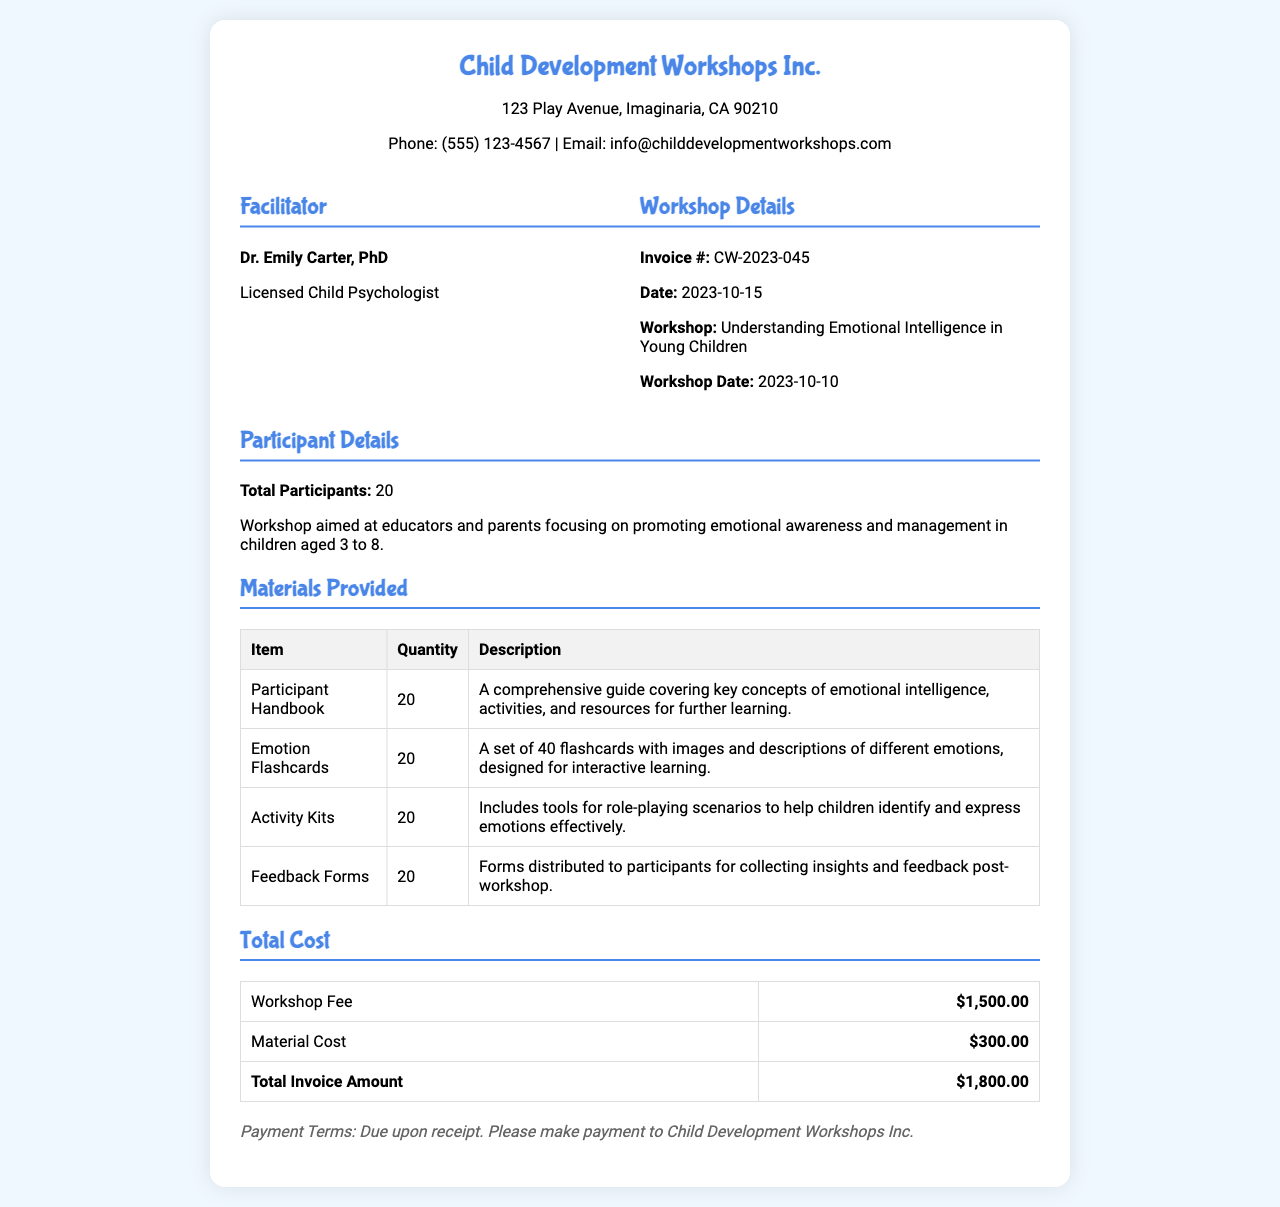What is the invoice number? The invoice number is specified in the workshop details section of the document as CW-2023-045.
Answer: CW-2023-045 Who is the facilitator's name? The facilitator's name is located under the facilitator details section, which states Dr. Emily Carter, PhD.
Answer: Dr. Emily Carter, PhD What is the total number of participants? The total number of participants is mentioned in the participant details section as 20.
Answer: 20 What is the date of the workshop? The workshop date is provided in the workshop details section as 2023-10-10.
Answer: 2023-10-10 What is the total invoice amount? The total invoice amount is calculated from the total cost section, which shows $1,800.00 as the final figure.
Answer: $1,800.00 How many Emotion Flashcards were provided? The quantity of Emotion Flashcards is listed in the materials provided table as 20.
Answer: 20 What is the main focus of the workshop? The main focus of the workshop is described in the participant details section as promoting emotional awareness and management in children aged 3 to 8.
Answer: Promoting emotional awareness and management What is the cost of materials? The cost of materials is provided in the total cost table as $300.00.
Answer: $300.00 What is the payment term stated in the invoice? The payment terms are noted at the bottom of the invoice as "Due upon receipt."
Answer: Due upon receipt 